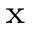<formula> <loc_0><loc_0><loc_500><loc_500>_ { x }</formula> 